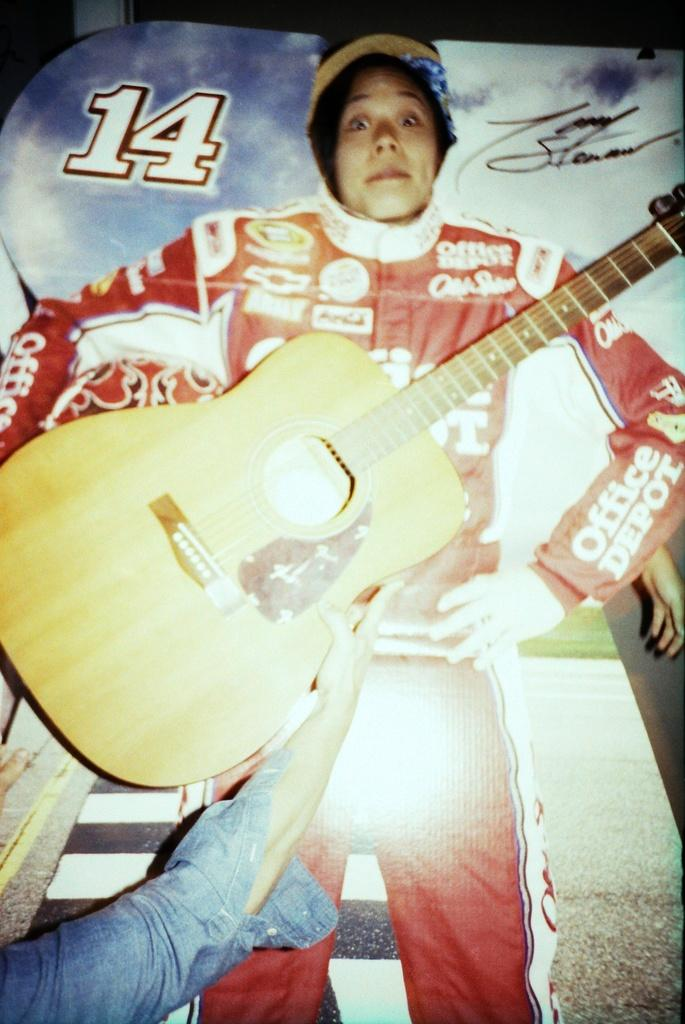Who is the main subject in the image? There is a girl in the image. What is the girl holding in the image? The girl is holding a guitar. What is the girl's posture in the image? The girl is standing. What type of poster is the image? The image is a flexi poster. Can you see a robin perched on the guitar in the image? No, there is no robin present in the image. How many visitors can be seen in the image? There are no visitors present in the image; it only features the girl holding a guitar. 